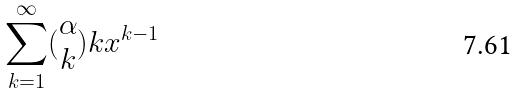Convert formula to latex. <formula><loc_0><loc_0><loc_500><loc_500>\sum _ { k = 1 } ^ { \infty } ( \begin{matrix} \alpha \\ k \end{matrix} ) k x ^ { k - 1 }</formula> 